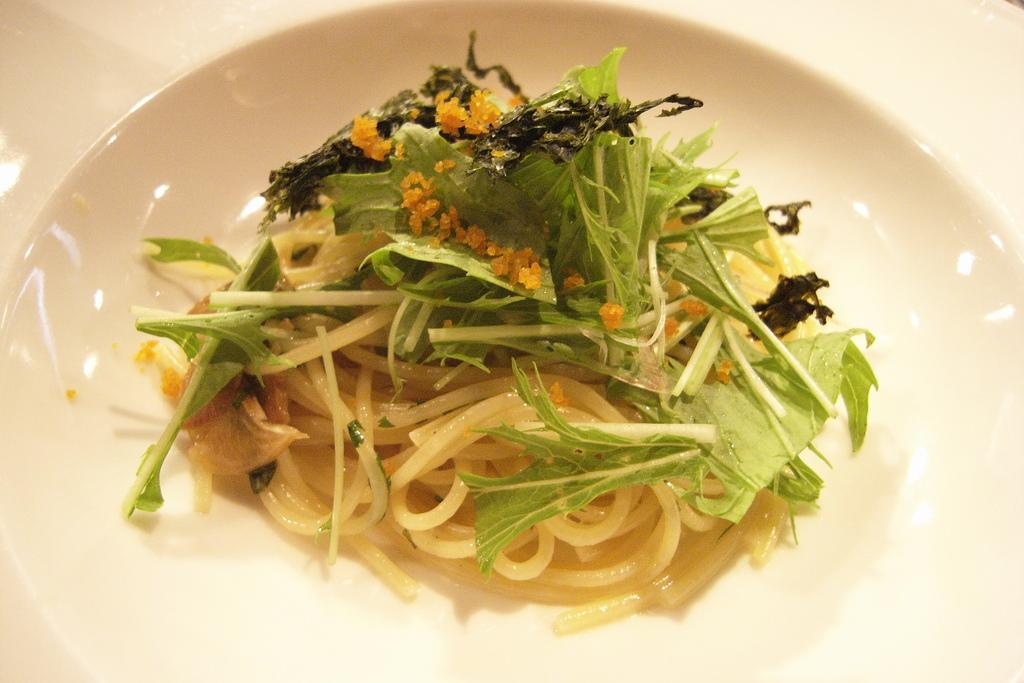What object is present in the image that typically holds food? There is a plate in the image that typically holds food. What type of food can be seen on the plate? The food contains spaghetti, onions, and green leafy vegetables. Can you describe the main components of the food on the plate? The food contains spaghetti, onions, and green leafy vegetables. What type of disease is visible on the plate in the image? There is no disease present in the image; it features a plate of food with spaghetti, onions, and green leafy vegetables. What type of toys can be seen playing with the food on the plate? There are no toys present in the image; it features a plate of food with spaghetti, onions, and green leafy vegetables. 